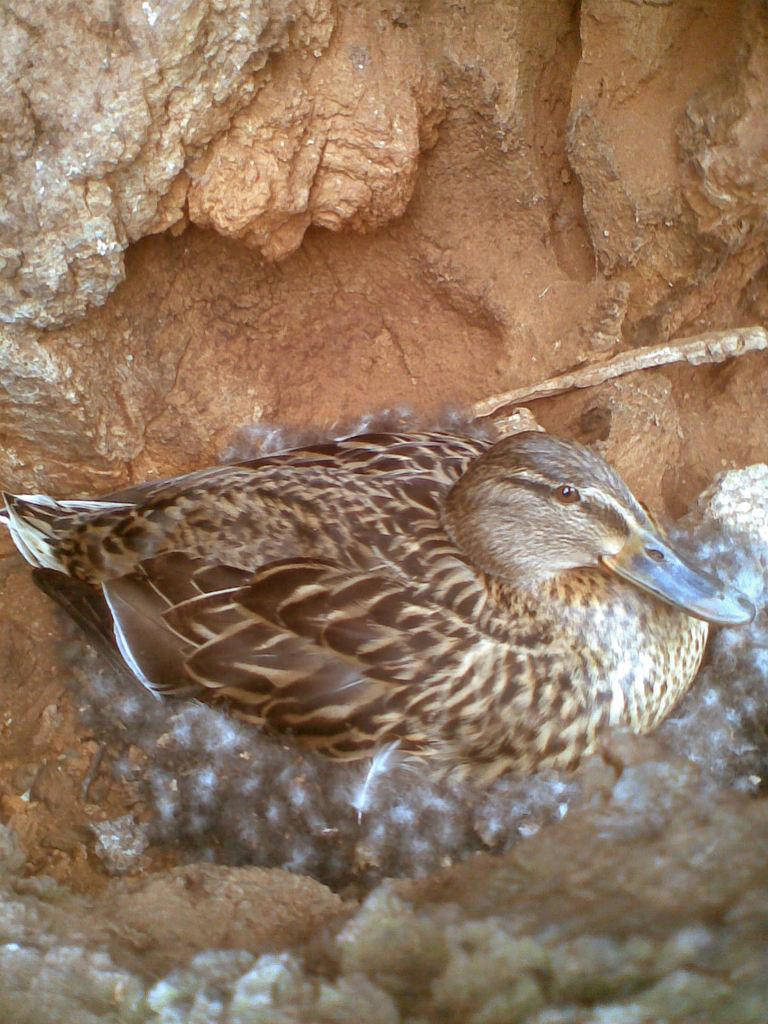What is the main subject of the image? There is a bird in a nest in the center of the image. Can you describe the bird's location? The bird is in a nest in the center of the image. What else can be seen in the background of the image? There is a rock visible in the background of the image. What type of meeting is taking place in the image? There is no meeting present in the image; it features a bird in a nest and a rock in the background. Can you describe the kiss between the two birds in the image? There are no birds kissing in the image; it only shows a bird in a nest. 